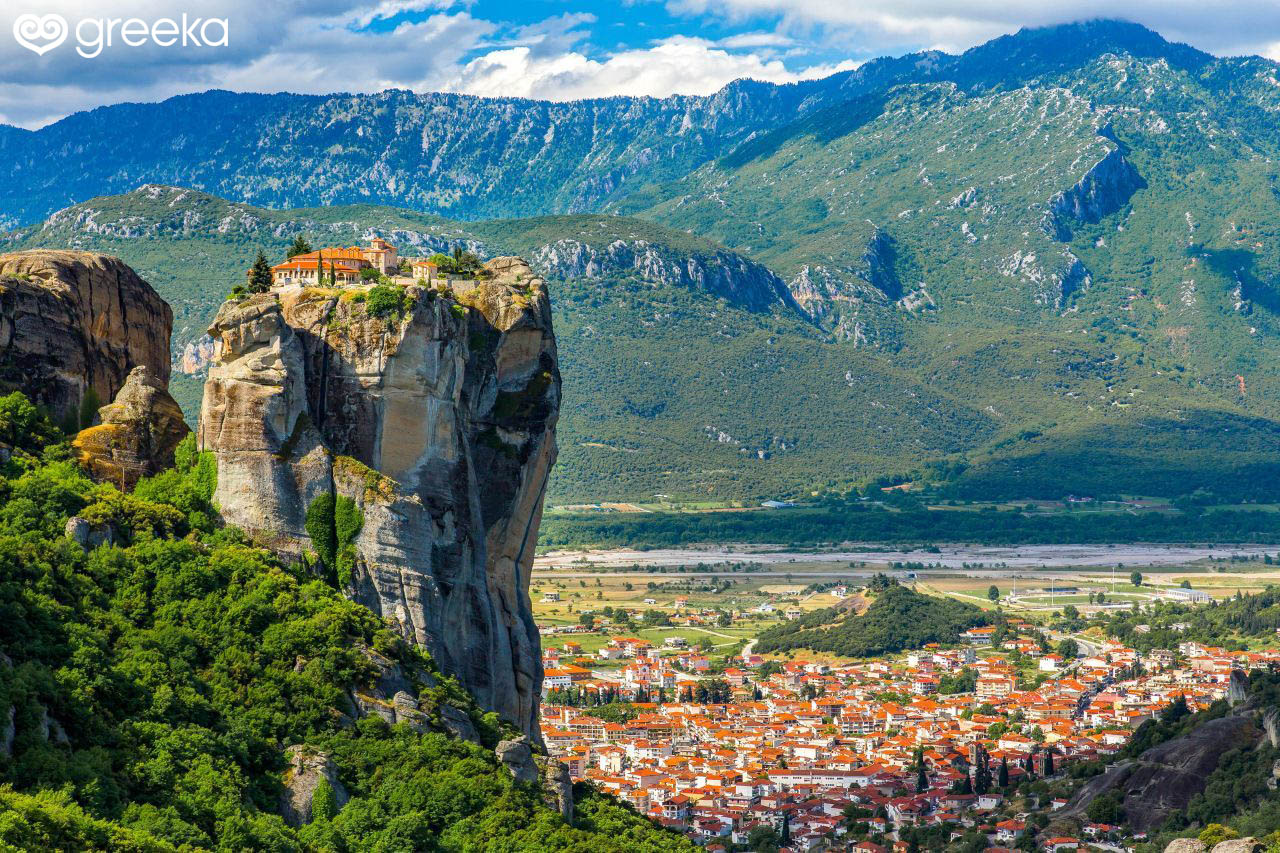Can you describe the significance of the structures on top of the rock formations? The structures atop the rock formations in Meteora are historical monasteries. These monasteries were built by hermit monks beginning in the 14th century as places of retreat, spiritual practice, and refuge from the political turbulence of the region. The inaccessibility of the steep cliffs provided the monks with solitude and protection, which were crucial for their way of life. Today, these monasteries are recognized as UNESCO World Heritage Sites and are significant for their architectural ingenuity, historical value, and religious importance. 